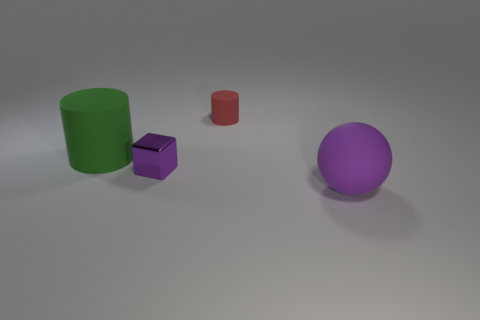There is a object that is the same size as the green cylinder; what is it made of?
Give a very brief answer. Rubber. How many large things are either gray matte things or purple matte balls?
Keep it short and to the point. 1. How many things are either large balls that are in front of the tiny metallic cube or large things that are on the right side of the green rubber cylinder?
Offer a very short reply. 1. Are there fewer cyan metal cylinders than small purple things?
Keep it short and to the point. Yes. There is a thing that is the same size as the block; what is its shape?
Provide a succinct answer. Cylinder. How many other things are there of the same color as the large cylinder?
Keep it short and to the point. 0. What number of small metal blocks are there?
Give a very brief answer. 1. What number of matte objects are both to the right of the small metallic object and behind the tiny shiny thing?
Make the answer very short. 1. What is the purple ball made of?
Offer a very short reply. Rubber. Are there any large purple objects?
Give a very brief answer. Yes. 